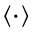Convert formula to latex. <formula><loc_0><loc_0><loc_500><loc_500>\langle \cdot \rangle</formula> 